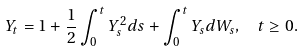<formula> <loc_0><loc_0><loc_500><loc_500>Y _ { t } = 1 + \frac { 1 } { 2 } \int _ { 0 } ^ { t } Y _ { s } ^ { 2 } d s + \int _ { 0 } ^ { t } Y _ { s } d W _ { s } , \ \ t \geq 0 .</formula> 